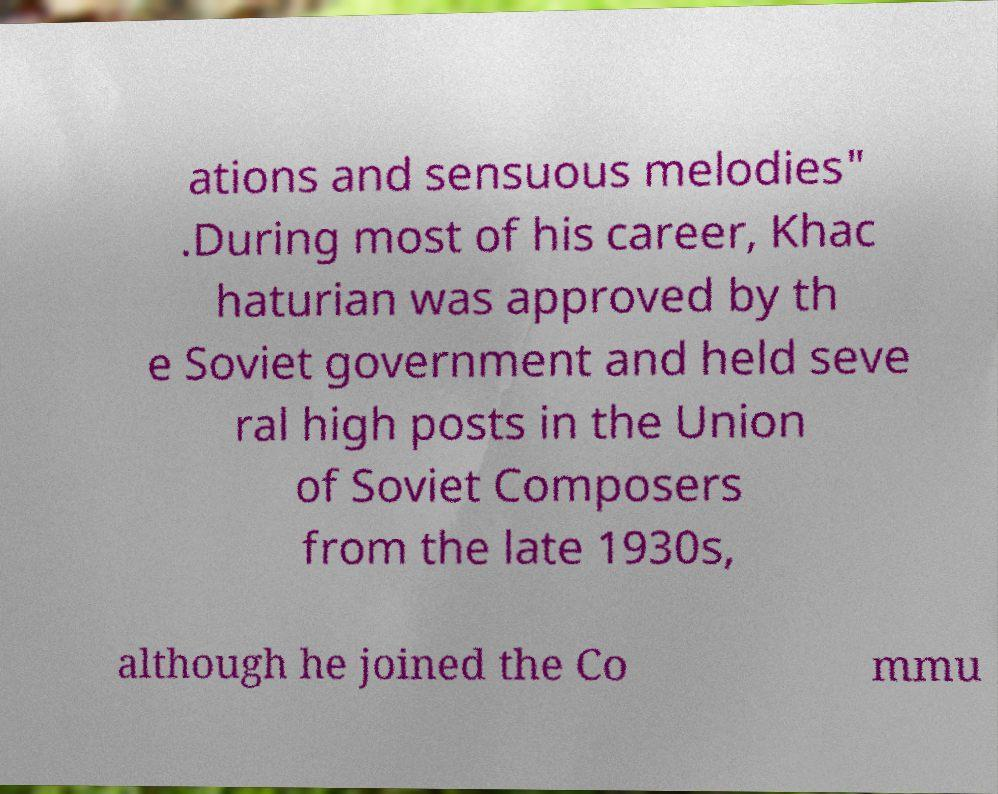There's text embedded in this image that I need extracted. Can you transcribe it verbatim? ations and sensuous melodies" .During most of his career, Khac haturian was approved by th e Soviet government and held seve ral high posts in the Union of Soviet Composers from the late 1930s, although he joined the Co mmu 